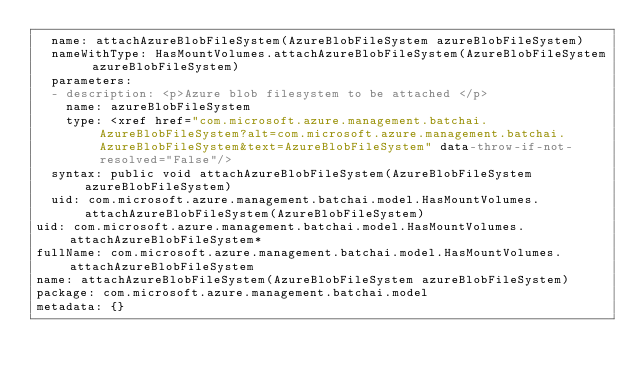<code> <loc_0><loc_0><loc_500><loc_500><_YAML_>  name: attachAzureBlobFileSystem(AzureBlobFileSystem azureBlobFileSystem)
  nameWithType: HasMountVolumes.attachAzureBlobFileSystem(AzureBlobFileSystem azureBlobFileSystem)
  parameters:
  - description: <p>Azure blob filesystem to be attached </p>
    name: azureBlobFileSystem
    type: <xref href="com.microsoft.azure.management.batchai.AzureBlobFileSystem?alt=com.microsoft.azure.management.batchai.AzureBlobFileSystem&text=AzureBlobFileSystem" data-throw-if-not-resolved="False"/>
  syntax: public void attachAzureBlobFileSystem(AzureBlobFileSystem azureBlobFileSystem)
  uid: com.microsoft.azure.management.batchai.model.HasMountVolumes.attachAzureBlobFileSystem(AzureBlobFileSystem)
uid: com.microsoft.azure.management.batchai.model.HasMountVolumes.attachAzureBlobFileSystem*
fullName: com.microsoft.azure.management.batchai.model.HasMountVolumes.attachAzureBlobFileSystem
name: attachAzureBlobFileSystem(AzureBlobFileSystem azureBlobFileSystem)
package: com.microsoft.azure.management.batchai.model
metadata: {}
</code> 